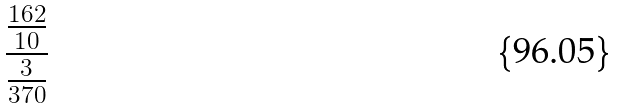Convert formula to latex. <formula><loc_0><loc_0><loc_500><loc_500>\frac { \frac { 1 6 2 } { 1 0 } } { \frac { 3 } { 3 7 0 } }</formula> 